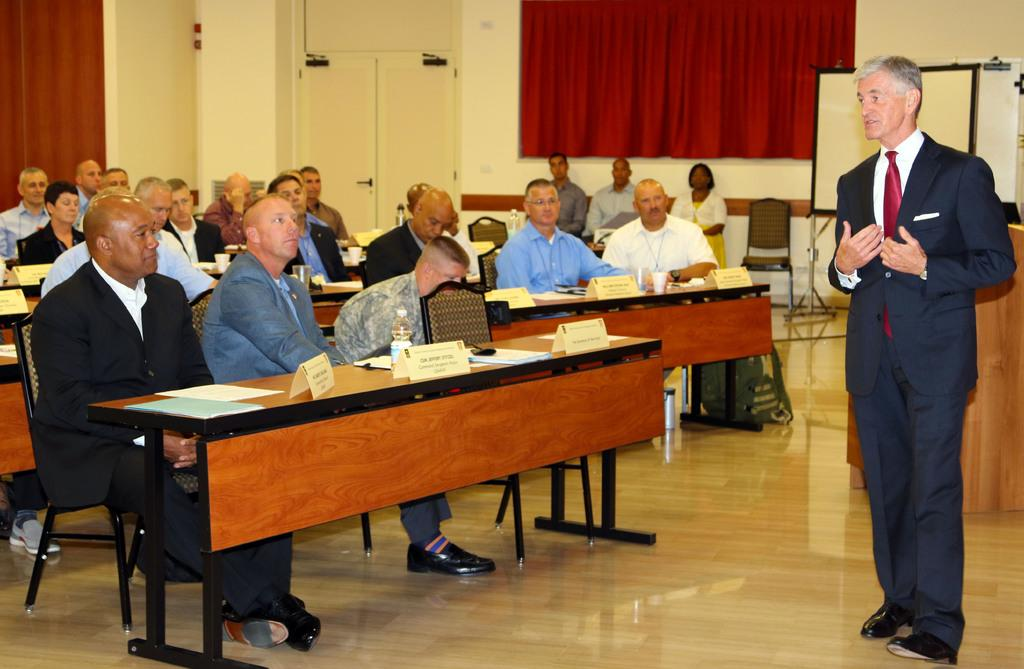What is the color of the wall in the image? The wall in the image is yellow. What can be found on the wall? There is a door in the image. What type of window treatment is present in the image? There is a curtain in the image. What is the purpose of the screen in the image? The screen's purpose is not specified, but it is visible in the image. What are the people in the image doing? The people are sitting on chairs in the image. What is on the table in the image? There is a table in the image with papers and bottles present. What type of cake is being served to the children in the image? There are no children or cake present in the image. What type of drink is being offered to the guests in the image? There is no mention of drinks or guests in the image. 